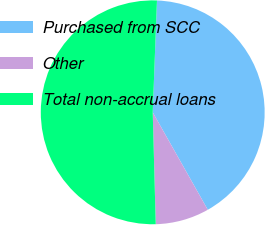<chart> <loc_0><loc_0><loc_500><loc_500><pie_chart><fcel>Purchased from SCC<fcel>Other<fcel>Total non-accrual loans<nl><fcel>41.21%<fcel>7.76%<fcel>51.03%<nl></chart> 